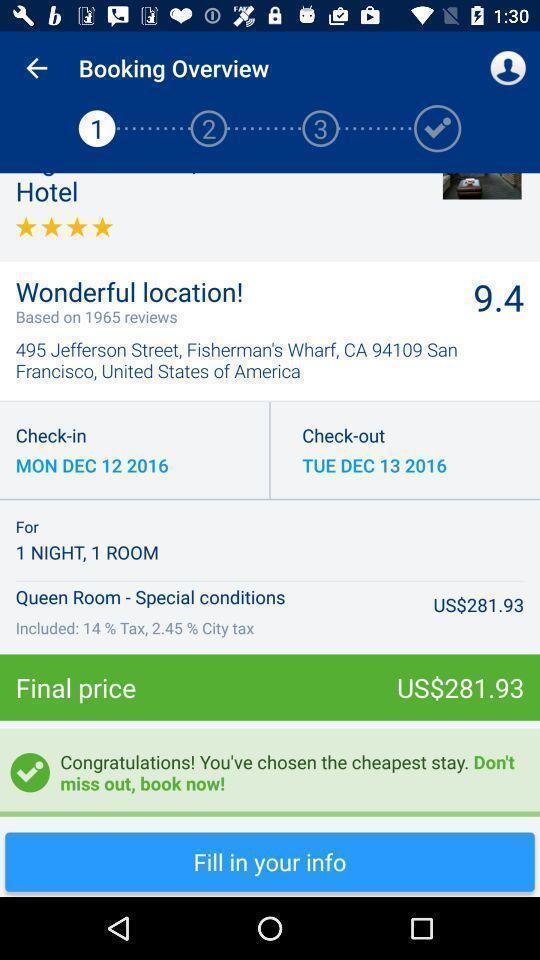Summarize the information in this screenshot. Page showing details of booking with final price. 